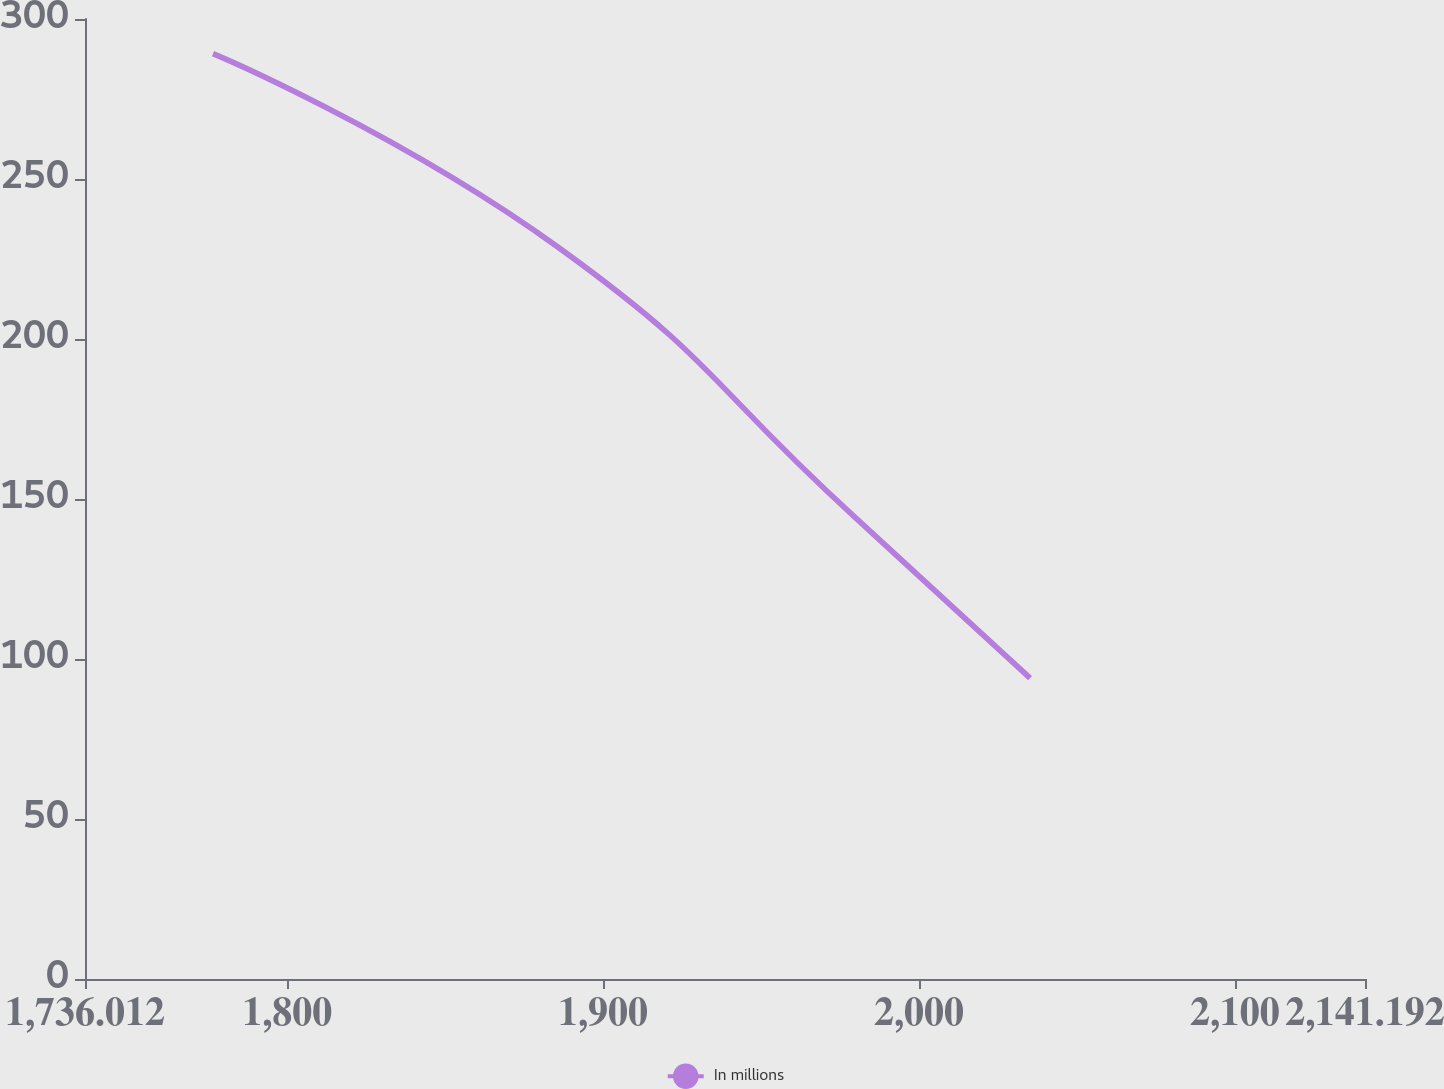<chart> <loc_0><loc_0><loc_500><loc_500><line_chart><ecel><fcel>In millions<nl><fcel>1776.53<fcel>289.18<nl><fcel>1886.17<fcel>228.4<nl><fcel>1979.78<fcel>144.25<nl><fcel>2035.18<fcel>94.04<nl><fcel>2181.71<fcel>113.55<nl></chart> 